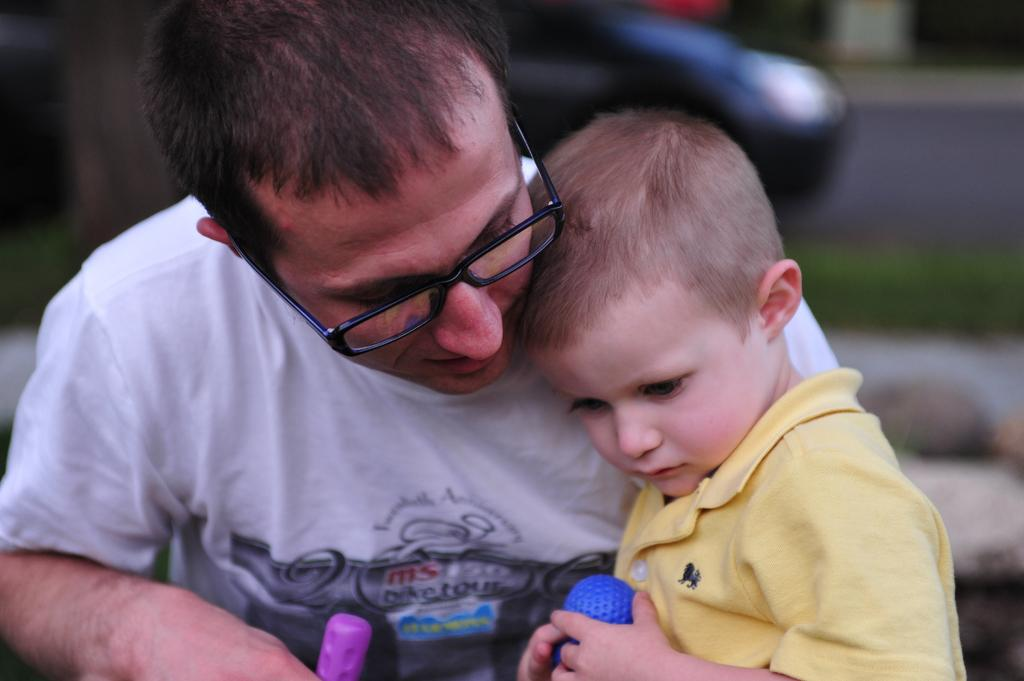Who are the people in the image? There is a man and a boy in the image. What are the man and the boy wearing? Both the man and the boy are wearing t-shirts. What are the man and the boy doing in the image? Both the man and the boy are looking downwards and holding objects in their hands. Can you describe the background of the image? The background of the image is blurred. What type of jam can be seen on the cushion in the image? There is no cushion or jam present in the image. 